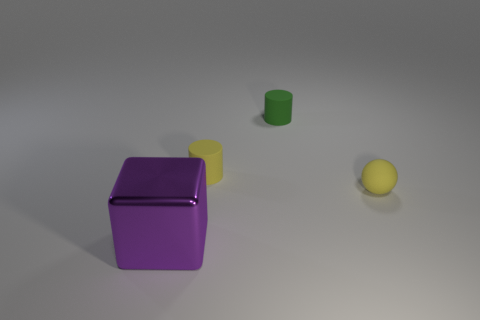What materials do the objects in the image appear to be made of? The objects in the image seem to have different textures indicating various materials. The purple object, which is a cube, appears to have a shiny, reflective surface, possibly plastic or polished metal. The flat yellow square has a matte finish, resembling painted wood or plastic, whereas the tiny green cylinder also has a matte appearance, suggesting it could be made of ceramic or matte plastic. Lastly, the yellow ball has a smooth texture that might indicate a rubber or plastic material. 